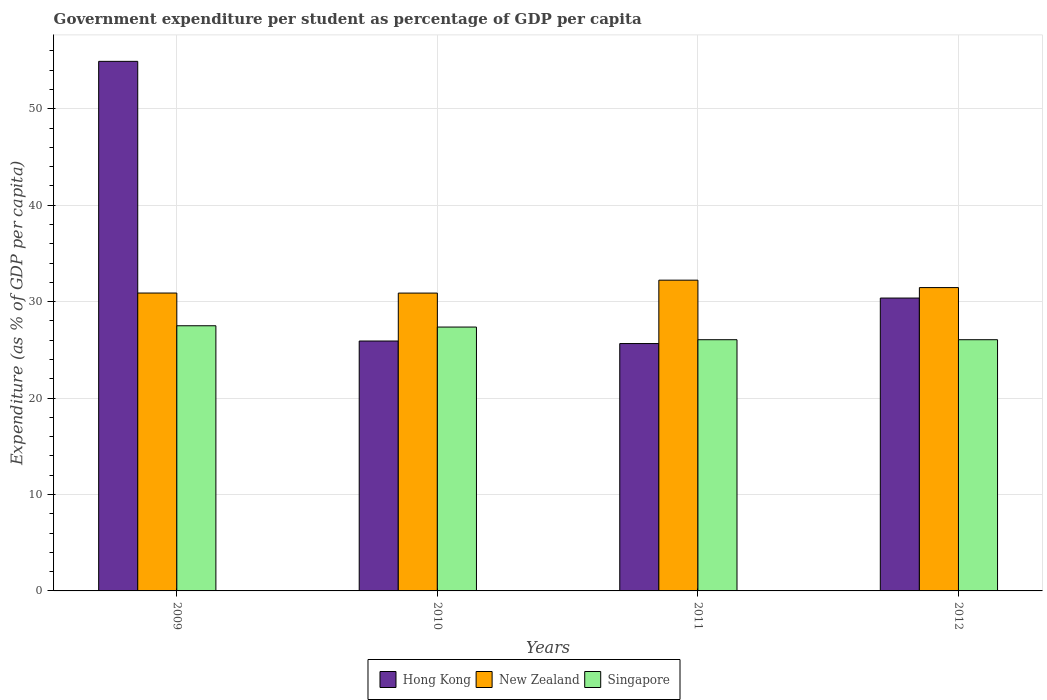Are the number of bars per tick equal to the number of legend labels?
Your answer should be very brief. Yes. Are the number of bars on each tick of the X-axis equal?
Offer a very short reply. Yes. How many bars are there on the 4th tick from the left?
Offer a very short reply. 3. In how many cases, is the number of bars for a given year not equal to the number of legend labels?
Make the answer very short. 0. What is the percentage of expenditure per student in Hong Kong in 2011?
Ensure brevity in your answer.  25.65. Across all years, what is the maximum percentage of expenditure per student in Singapore?
Your answer should be very brief. 27.5. Across all years, what is the minimum percentage of expenditure per student in Singapore?
Offer a very short reply. 26.05. In which year was the percentage of expenditure per student in New Zealand minimum?
Offer a terse response. 2010. What is the total percentage of expenditure per student in Singapore in the graph?
Your response must be concise. 106.97. What is the difference between the percentage of expenditure per student in Hong Kong in 2009 and that in 2010?
Keep it short and to the point. 29. What is the difference between the percentage of expenditure per student in New Zealand in 2010 and the percentage of expenditure per student in Singapore in 2009?
Provide a succinct answer. 3.39. What is the average percentage of expenditure per student in New Zealand per year?
Make the answer very short. 31.37. In the year 2011, what is the difference between the percentage of expenditure per student in Singapore and percentage of expenditure per student in Hong Kong?
Your answer should be compact. 0.4. In how many years, is the percentage of expenditure per student in Singapore greater than 52 %?
Your answer should be very brief. 0. What is the ratio of the percentage of expenditure per student in New Zealand in 2010 to that in 2012?
Your response must be concise. 0.98. Is the percentage of expenditure per student in Hong Kong in 2009 less than that in 2012?
Keep it short and to the point. No. What is the difference between the highest and the second highest percentage of expenditure per student in Hong Kong?
Your answer should be compact. 24.55. What is the difference between the highest and the lowest percentage of expenditure per student in New Zealand?
Keep it short and to the point. 1.34. What does the 1st bar from the left in 2010 represents?
Offer a terse response. Hong Kong. What does the 1st bar from the right in 2009 represents?
Your answer should be compact. Singapore. What is the difference between two consecutive major ticks on the Y-axis?
Your answer should be compact. 10. Does the graph contain any zero values?
Your answer should be compact. No. Does the graph contain grids?
Provide a succinct answer. Yes. How many legend labels are there?
Provide a short and direct response. 3. What is the title of the graph?
Your answer should be very brief. Government expenditure per student as percentage of GDP per capita. What is the label or title of the X-axis?
Offer a very short reply. Years. What is the label or title of the Y-axis?
Provide a succinct answer. Expenditure (as % of GDP per capita). What is the Expenditure (as % of GDP per capita) in Hong Kong in 2009?
Your answer should be compact. 54.92. What is the Expenditure (as % of GDP per capita) of New Zealand in 2009?
Ensure brevity in your answer.  30.89. What is the Expenditure (as % of GDP per capita) of Singapore in 2009?
Provide a succinct answer. 27.5. What is the Expenditure (as % of GDP per capita) in Hong Kong in 2010?
Keep it short and to the point. 25.92. What is the Expenditure (as % of GDP per capita) in New Zealand in 2010?
Your response must be concise. 30.89. What is the Expenditure (as % of GDP per capita) in Singapore in 2010?
Make the answer very short. 27.37. What is the Expenditure (as % of GDP per capita) in Hong Kong in 2011?
Your response must be concise. 25.65. What is the Expenditure (as % of GDP per capita) in New Zealand in 2011?
Give a very brief answer. 32.23. What is the Expenditure (as % of GDP per capita) of Singapore in 2011?
Your answer should be compact. 26.05. What is the Expenditure (as % of GDP per capita) of Hong Kong in 2012?
Provide a short and direct response. 30.37. What is the Expenditure (as % of GDP per capita) in New Zealand in 2012?
Make the answer very short. 31.46. What is the Expenditure (as % of GDP per capita) in Singapore in 2012?
Give a very brief answer. 26.05. Across all years, what is the maximum Expenditure (as % of GDP per capita) of Hong Kong?
Provide a succinct answer. 54.92. Across all years, what is the maximum Expenditure (as % of GDP per capita) of New Zealand?
Your response must be concise. 32.23. Across all years, what is the maximum Expenditure (as % of GDP per capita) of Singapore?
Keep it short and to the point. 27.5. Across all years, what is the minimum Expenditure (as % of GDP per capita) of Hong Kong?
Give a very brief answer. 25.65. Across all years, what is the minimum Expenditure (as % of GDP per capita) of New Zealand?
Your response must be concise. 30.89. Across all years, what is the minimum Expenditure (as % of GDP per capita) in Singapore?
Your answer should be very brief. 26.05. What is the total Expenditure (as % of GDP per capita) of Hong Kong in the graph?
Offer a terse response. 136.87. What is the total Expenditure (as % of GDP per capita) of New Zealand in the graph?
Keep it short and to the point. 125.47. What is the total Expenditure (as % of GDP per capita) in Singapore in the graph?
Give a very brief answer. 106.97. What is the difference between the Expenditure (as % of GDP per capita) in Hong Kong in 2009 and that in 2010?
Keep it short and to the point. 29. What is the difference between the Expenditure (as % of GDP per capita) of New Zealand in 2009 and that in 2010?
Make the answer very short. 0. What is the difference between the Expenditure (as % of GDP per capita) in Singapore in 2009 and that in 2010?
Offer a terse response. 0.13. What is the difference between the Expenditure (as % of GDP per capita) in Hong Kong in 2009 and that in 2011?
Provide a short and direct response. 29.27. What is the difference between the Expenditure (as % of GDP per capita) in New Zealand in 2009 and that in 2011?
Make the answer very short. -1.33. What is the difference between the Expenditure (as % of GDP per capita) in Singapore in 2009 and that in 2011?
Offer a very short reply. 1.45. What is the difference between the Expenditure (as % of GDP per capita) of Hong Kong in 2009 and that in 2012?
Offer a very short reply. 24.55. What is the difference between the Expenditure (as % of GDP per capita) in New Zealand in 2009 and that in 2012?
Offer a terse response. -0.57. What is the difference between the Expenditure (as % of GDP per capita) of Singapore in 2009 and that in 2012?
Give a very brief answer. 1.45. What is the difference between the Expenditure (as % of GDP per capita) of Hong Kong in 2010 and that in 2011?
Offer a terse response. 0.26. What is the difference between the Expenditure (as % of GDP per capita) of New Zealand in 2010 and that in 2011?
Your response must be concise. -1.34. What is the difference between the Expenditure (as % of GDP per capita) of Singapore in 2010 and that in 2011?
Offer a very short reply. 1.31. What is the difference between the Expenditure (as % of GDP per capita) in Hong Kong in 2010 and that in 2012?
Your response must be concise. -4.46. What is the difference between the Expenditure (as % of GDP per capita) of New Zealand in 2010 and that in 2012?
Ensure brevity in your answer.  -0.57. What is the difference between the Expenditure (as % of GDP per capita) of Singapore in 2010 and that in 2012?
Provide a succinct answer. 1.31. What is the difference between the Expenditure (as % of GDP per capita) of Hong Kong in 2011 and that in 2012?
Provide a succinct answer. -4.72. What is the difference between the Expenditure (as % of GDP per capita) of New Zealand in 2011 and that in 2012?
Provide a succinct answer. 0.77. What is the difference between the Expenditure (as % of GDP per capita) in Hong Kong in 2009 and the Expenditure (as % of GDP per capita) in New Zealand in 2010?
Give a very brief answer. 24.03. What is the difference between the Expenditure (as % of GDP per capita) of Hong Kong in 2009 and the Expenditure (as % of GDP per capita) of Singapore in 2010?
Your answer should be very brief. 27.56. What is the difference between the Expenditure (as % of GDP per capita) in New Zealand in 2009 and the Expenditure (as % of GDP per capita) in Singapore in 2010?
Offer a very short reply. 3.53. What is the difference between the Expenditure (as % of GDP per capita) of Hong Kong in 2009 and the Expenditure (as % of GDP per capita) of New Zealand in 2011?
Give a very brief answer. 22.69. What is the difference between the Expenditure (as % of GDP per capita) in Hong Kong in 2009 and the Expenditure (as % of GDP per capita) in Singapore in 2011?
Your response must be concise. 28.87. What is the difference between the Expenditure (as % of GDP per capita) in New Zealand in 2009 and the Expenditure (as % of GDP per capita) in Singapore in 2011?
Keep it short and to the point. 4.84. What is the difference between the Expenditure (as % of GDP per capita) in Hong Kong in 2009 and the Expenditure (as % of GDP per capita) in New Zealand in 2012?
Provide a short and direct response. 23.46. What is the difference between the Expenditure (as % of GDP per capita) of Hong Kong in 2009 and the Expenditure (as % of GDP per capita) of Singapore in 2012?
Provide a succinct answer. 28.87. What is the difference between the Expenditure (as % of GDP per capita) of New Zealand in 2009 and the Expenditure (as % of GDP per capita) of Singapore in 2012?
Make the answer very short. 4.84. What is the difference between the Expenditure (as % of GDP per capita) in Hong Kong in 2010 and the Expenditure (as % of GDP per capita) in New Zealand in 2011?
Your response must be concise. -6.31. What is the difference between the Expenditure (as % of GDP per capita) in Hong Kong in 2010 and the Expenditure (as % of GDP per capita) in Singapore in 2011?
Offer a terse response. -0.14. What is the difference between the Expenditure (as % of GDP per capita) in New Zealand in 2010 and the Expenditure (as % of GDP per capita) in Singapore in 2011?
Keep it short and to the point. 4.84. What is the difference between the Expenditure (as % of GDP per capita) of Hong Kong in 2010 and the Expenditure (as % of GDP per capita) of New Zealand in 2012?
Provide a succinct answer. -5.54. What is the difference between the Expenditure (as % of GDP per capita) of Hong Kong in 2010 and the Expenditure (as % of GDP per capita) of Singapore in 2012?
Keep it short and to the point. -0.13. What is the difference between the Expenditure (as % of GDP per capita) in New Zealand in 2010 and the Expenditure (as % of GDP per capita) in Singapore in 2012?
Ensure brevity in your answer.  4.84. What is the difference between the Expenditure (as % of GDP per capita) of Hong Kong in 2011 and the Expenditure (as % of GDP per capita) of New Zealand in 2012?
Your response must be concise. -5.81. What is the difference between the Expenditure (as % of GDP per capita) of Hong Kong in 2011 and the Expenditure (as % of GDP per capita) of Singapore in 2012?
Your answer should be very brief. -0.4. What is the difference between the Expenditure (as % of GDP per capita) of New Zealand in 2011 and the Expenditure (as % of GDP per capita) of Singapore in 2012?
Provide a succinct answer. 6.18. What is the average Expenditure (as % of GDP per capita) of Hong Kong per year?
Give a very brief answer. 34.22. What is the average Expenditure (as % of GDP per capita) in New Zealand per year?
Offer a very short reply. 31.37. What is the average Expenditure (as % of GDP per capita) of Singapore per year?
Offer a very short reply. 26.74. In the year 2009, what is the difference between the Expenditure (as % of GDP per capita) in Hong Kong and Expenditure (as % of GDP per capita) in New Zealand?
Give a very brief answer. 24.03. In the year 2009, what is the difference between the Expenditure (as % of GDP per capita) in Hong Kong and Expenditure (as % of GDP per capita) in Singapore?
Your answer should be very brief. 27.42. In the year 2009, what is the difference between the Expenditure (as % of GDP per capita) of New Zealand and Expenditure (as % of GDP per capita) of Singapore?
Your answer should be very brief. 3.39. In the year 2010, what is the difference between the Expenditure (as % of GDP per capita) in Hong Kong and Expenditure (as % of GDP per capita) in New Zealand?
Your response must be concise. -4.97. In the year 2010, what is the difference between the Expenditure (as % of GDP per capita) of Hong Kong and Expenditure (as % of GDP per capita) of Singapore?
Give a very brief answer. -1.45. In the year 2010, what is the difference between the Expenditure (as % of GDP per capita) in New Zealand and Expenditure (as % of GDP per capita) in Singapore?
Ensure brevity in your answer.  3.52. In the year 2011, what is the difference between the Expenditure (as % of GDP per capita) in Hong Kong and Expenditure (as % of GDP per capita) in New Zealand?
Your answer should be compact. -6.57. In the year 2011, what is the difference between the Expenditure (as % of GDP per capita) in Hong Kong and Expenditure (as % of GDP per capita) in Singapore?
Offer a terse response. -0.4. In the year 2011, what is the difference between the Expenditure (as % of GDP per capita) in New Zealand and Expenditure (as % of GDP per capita) in Singapore?
Your answer should be compact. 6.18. In the year 2012, what is the difference between the Expenditure (as % of GDP per capita) of Hong Kong and Expenditure (as % of GDP per capita) of New Zealand?
Provide a short and direct response. -1.09. In the year 2012, what is the difference between the Expenditure (as % of GDP per capita) in Hong Kong and Expenditure (as % of GDP per capita) in Singapore?
Make the answer very short. 4.32. In the year 2012, what is the difference between the Expenditure (as % of GDP per capita) in New Zealand and Expenditure (as % of GDP per capita) in Singapore?
Keep it short and to the point. 5.41. What is the ratio of the Expenditure (as % of GDP per capita) in Hong Kong in 2009 to that in 2010?
Offer a terse response. 2.12. What is the ratio of the Expenditure (as % of GDP per capita) of New Zealand in 2009 to that in 2010?
Provide a short and direct response. 1. What is the ratio of the Expenditure (as % of GDP per capita) in Hong Kong in 2009 to that in 2011?
Make the answer very short. 2.14. What is the ratio of the Expenditure (as % of GDP per capita) of New Zealand in 2009 to that in 2011?
Your answer should be very brief. 0.96. What is the ratio of the Expenditure (as % of GDP per capita) of Singapore in 2009 to that in 2011?
Ensure brevity in your answer.  1.06. What is the ratio of the Expenditure (as % of GDP per capita) of Hong Kong in 2009 to that in 2012?
Give a very brief answer. 1.81. What is the ratio of the Expenditure (as % of GDP per capita) of Singapore in 2009 to that in 2012?
Offer a terse response. 1.06. What is the ratio of the Expenditure (as % of GDP per capita) in Hong Kong in 2010 to that in 2011?
Offer a very short reply. 1.01. What is the ratio of the Expenditure (as % of GDP per capita) of New Zealand in 2010 to that in 2011?
Your response must be concise. 0.96. What is the ratio of the Expenditure (as % of GDP per capita) in Singapore in 2010 to that in 2011?
Ensure brevity in your answer.  1.05. What is the ratio of the Expenditure (as % of GDP per capita) in Hong Kong in 2010 to that in 2012?
Offer a very short reply. 0.85. What is the ratio of the Expenditure (as % of GDP per capita) of New Zealand in 2010 to that in 2012?
Offer a terse response. 0.98. What is the ratio of the Expenditure (as % of GDP per capita) of Singapore in 2010 to that in 2012?
Ensure brevity in your answer.  1.05. What is the ratio of the Expenditure (as % of GDP per capita) in Hong Kong in 2011 to that in 2012?
Offer a very short reply. 0.84. What is the ratio of the Expenditure (as % of GDP per capita) in New Zealand in 2011 to that in 2012?
Keep it short and to the point. 1.02. What is the ratio of the Expenditure (as % of GDP per capita) of Singapore in 2011 to that in 2012?
Offer a terse response. 1. What is the difference between the highest and the second highest Expenditure (as % of GDP per capita) in Hong Kong?
Your answer should be very brief. 24.55. What is the difference between the highest and the second highest Expenditure (as % of GDP per capita) of New Zealand?
Offer a very short reply. 0.77. What is the difference between the highest and the second highest Expenditure (as % of GDP per capita) of Singapore?
Your response must be concise. 0.13. What is the difference between the highest and the lowest Expenditure (as % of GDP per capita) of Hong Kong?
Your response must be concise. 29.27. What is the difference between the highest and the lowest Expenditure (as % of GDP per capita) in New Zealand?
Your response must be concise. 1.34. What is the difference between the highest and the lowest Expenditure (as % of GDP per capita) of Singapore?
Make the answer very short. 1.45. 